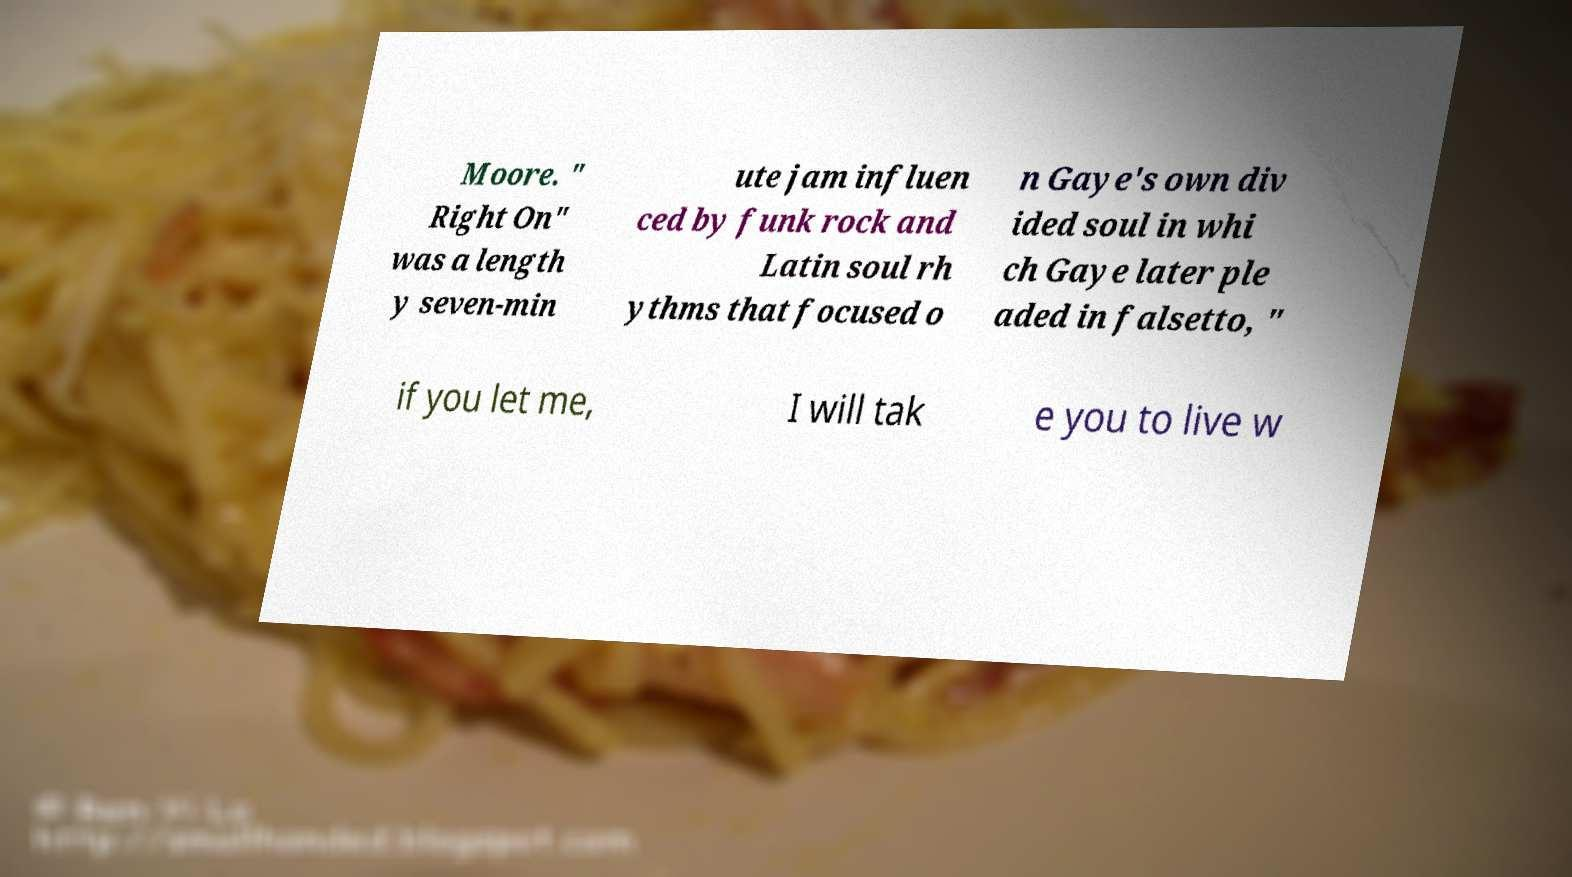What messages or text are displayed in this image? I need them in a readable, typed format. Moore. " Right On" was a length y seven-min ute jam influen ced by funk rock and Latin soul rh ythms that focused o n Gaye's own div ided soul in whi ch Gaye later ple aded in falsetto, " if you let me, I will tak e you to live w 